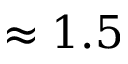Convert formula to latex. <formula><loc_0><loc_0><loc_500><loc_500>\approx 1 . 5</formula> 